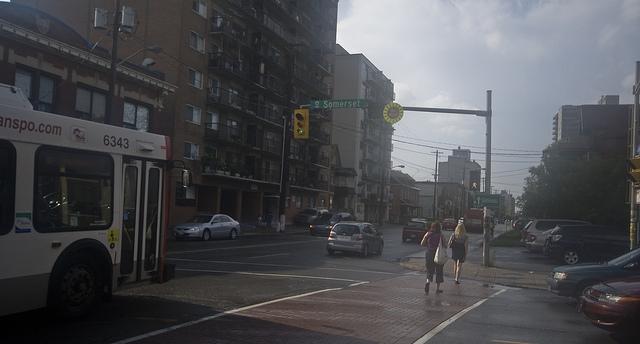Where is the street sign?
Short answer required. Above street. Where are the women walking?
Give a very brief answer. Crosswalk. Is the light green?
Concise answer only. Yes. What is written on the street?
Quick response, please. Somerset. Is it raining?
Concise answer only. No. Urban or suburban?
Quick response, please. Urban. Where is the woman standing?
Quick response, please. Crosswalk. How many people can be seen?
Short answer required. 2. What type of vehicle is on the left?
Concise answer only. Bus. Is this woman crossing a street?
Concise answer only. Yes. What color is the traffic signal?
Answer briefly. Green. What is being held green?
Keep it brief. Light. What time of day is it?
Short answer required. Afternoon. Is this in the United States?
Keep it brief. Yes. How many green lights are there?
Keep it brief. 1. 